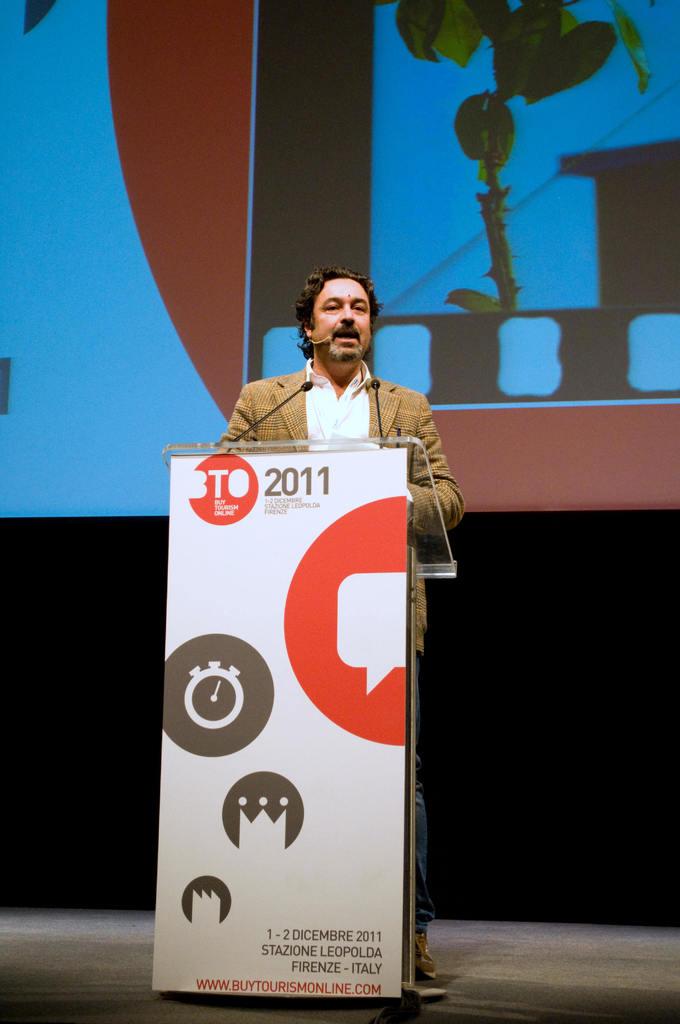What year is on the podium?
Keep it short and to the point. 2011. In which european country does this conference take place?
Offer a terse response. Italy. 